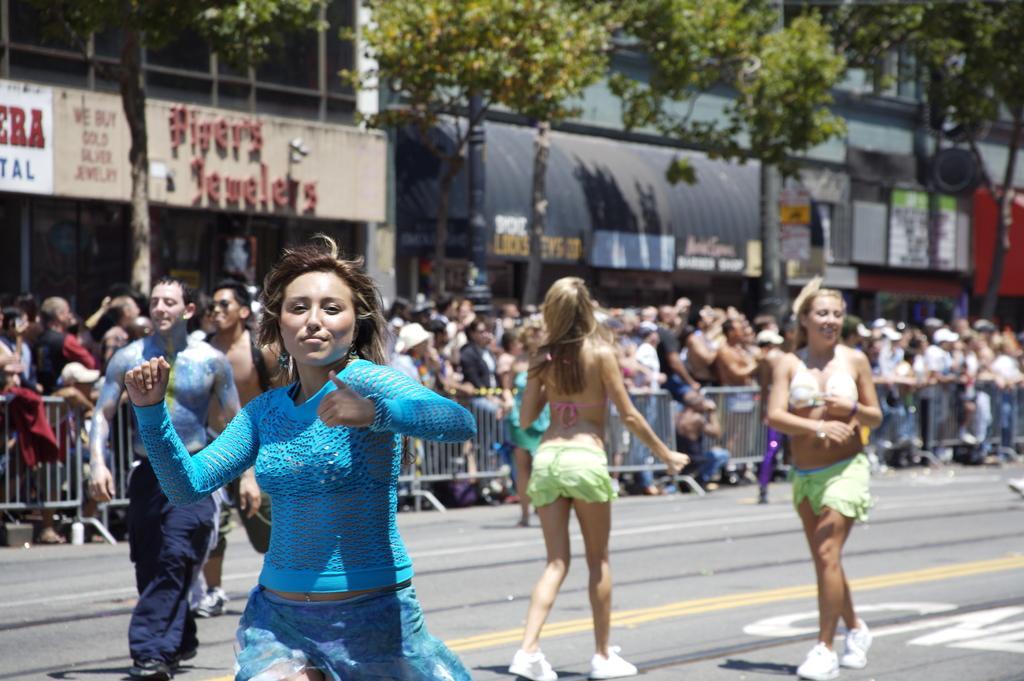How would you summarize this image in a sentence or two? Front these people are on the road. Background it is blurry and we can see crowd, fence, buildings, trees and hoardings. 